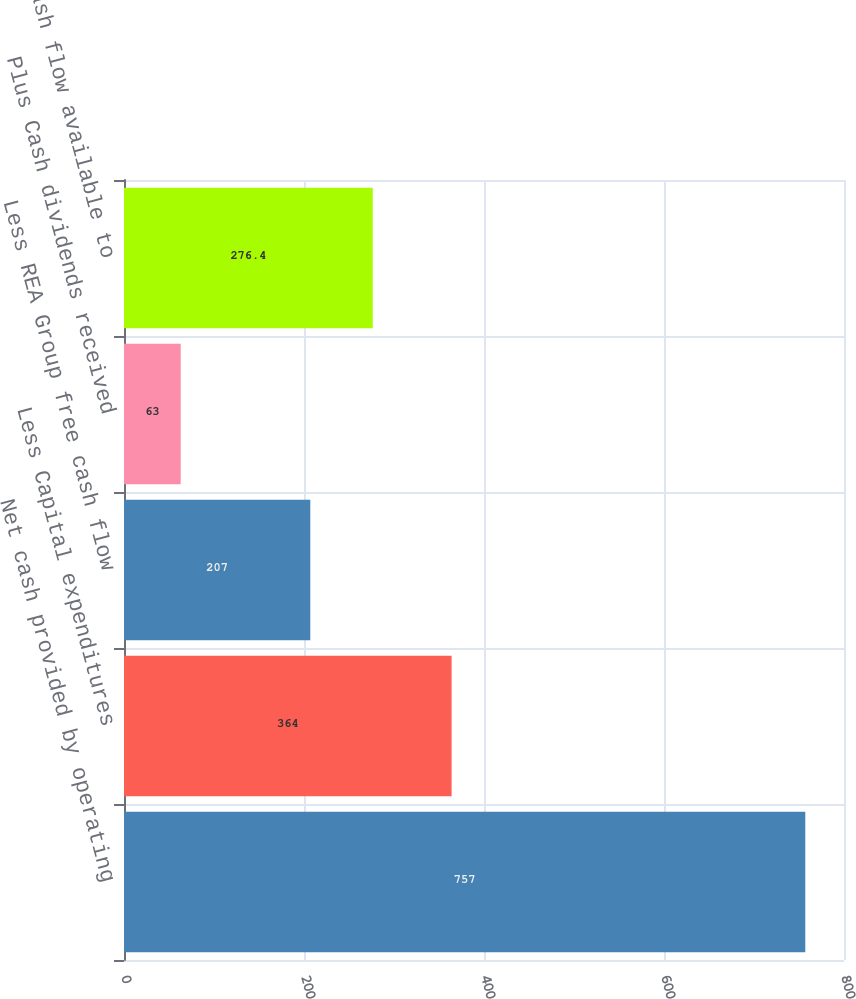<chart> <loc_0><loc_0><loc_500><loc_500><bar_chart><fcel>Net cash provided by operating<fcel>Less Capital expenditures<fcel>Less REA Group free cash flow<fcel>Plus Cash dividends received<fcel>Free cash flow available to<nl><fcel>757<fcel>364<fcel>207<fcel>63<fcel>276.4<nl></chart> 